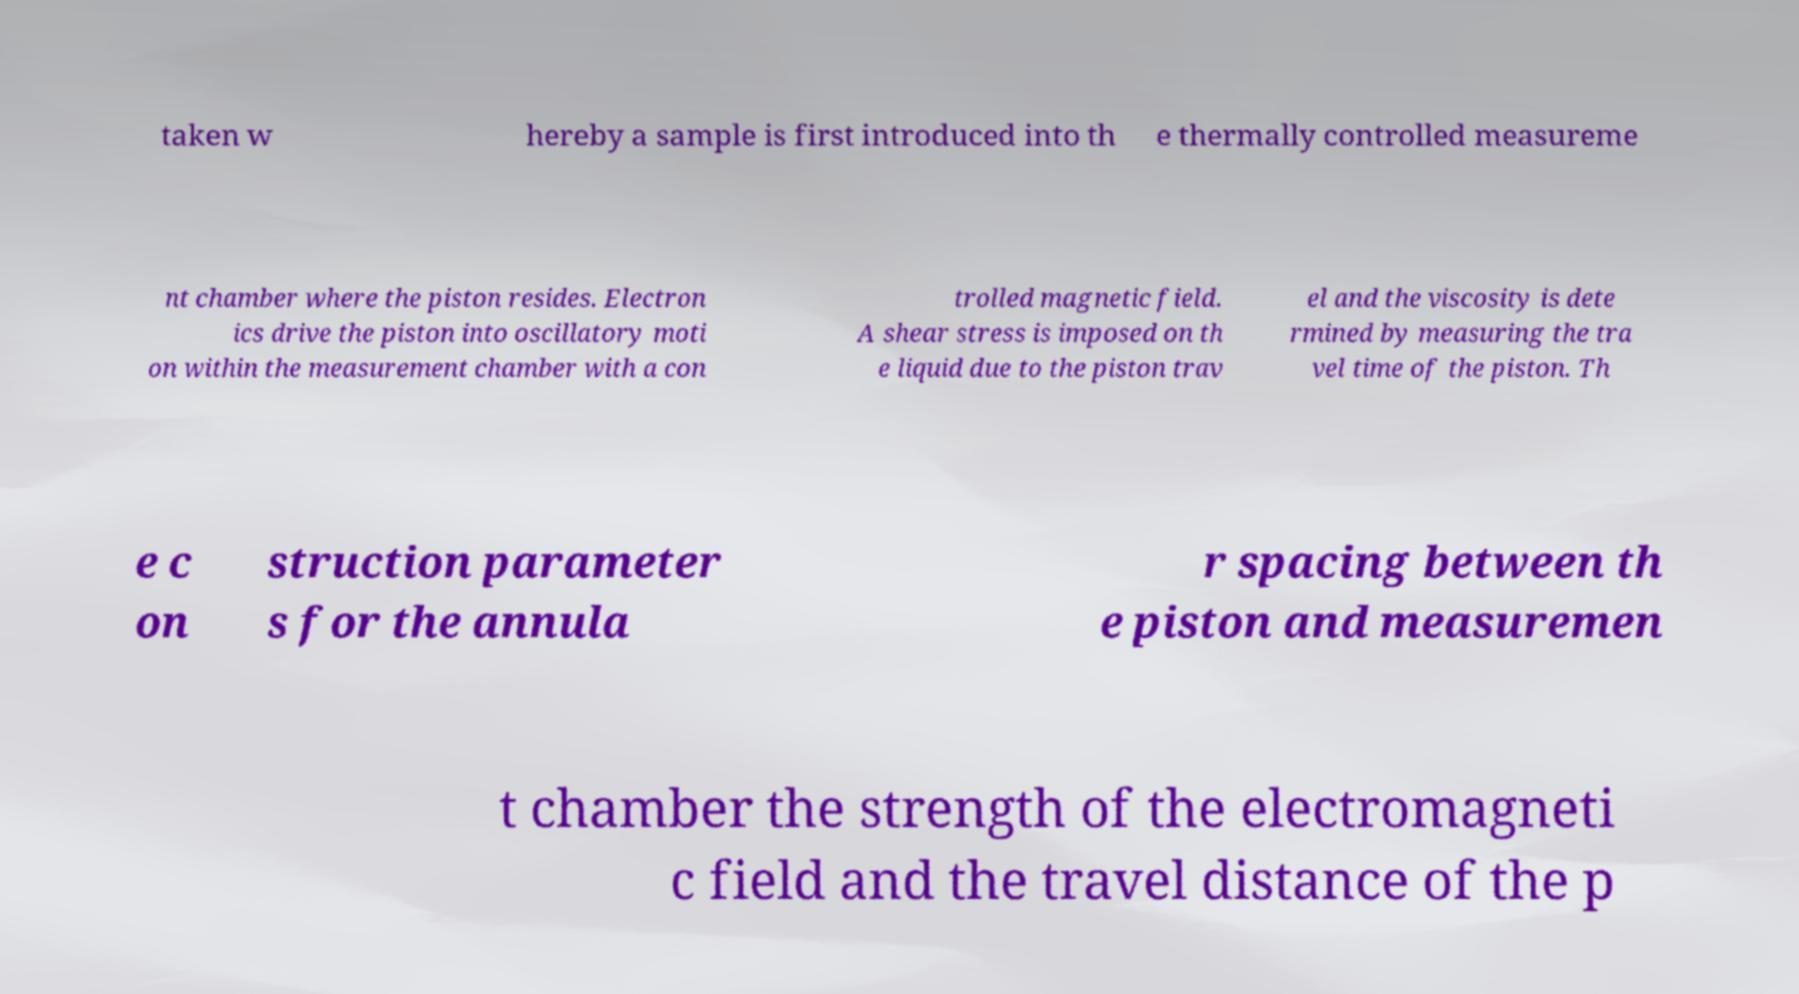Can you accurately transcribe the text from the provided image for me? taken w hereby a sample is first introduced into th e thermally controlled measureme nt chamber where the piston resides. Electron ics drive the piston into oscillatory moti on within the measurement chamber with a con trolled magnetic field. A shear stress is imposed on th e liquid due to the piston trav el and the viscosity is dete rmined by measuring the tra vel time of the piston. Th e c on struction parameter s for the annula r spacing between th e piston and measuremen t chamber the strength of the electromagneti c field and the travel distance of the p 